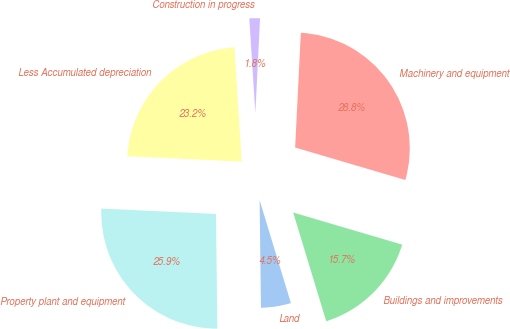Convert chart to OTSL. <chart><loc_0><loc_0><loc_500><loc_500><pie_chart><fcel>Land<fcel>Buildings and improvements<fcel>Machinery and equipment<fcel>Construction in progress<fcel>Less Accumulated depreciation<fcel>Property plant and equipment<nl><fcel>4.5%<fcel>15.74%<fcel>28.77%<fcel>1.8%<fcel>23.24%<fcel>25.94%<nl></chart> 